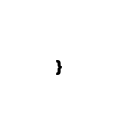Convert code to text. <code><loc_0><loc_0><loc_500><loc_500><_TypeScript_>}</code> 